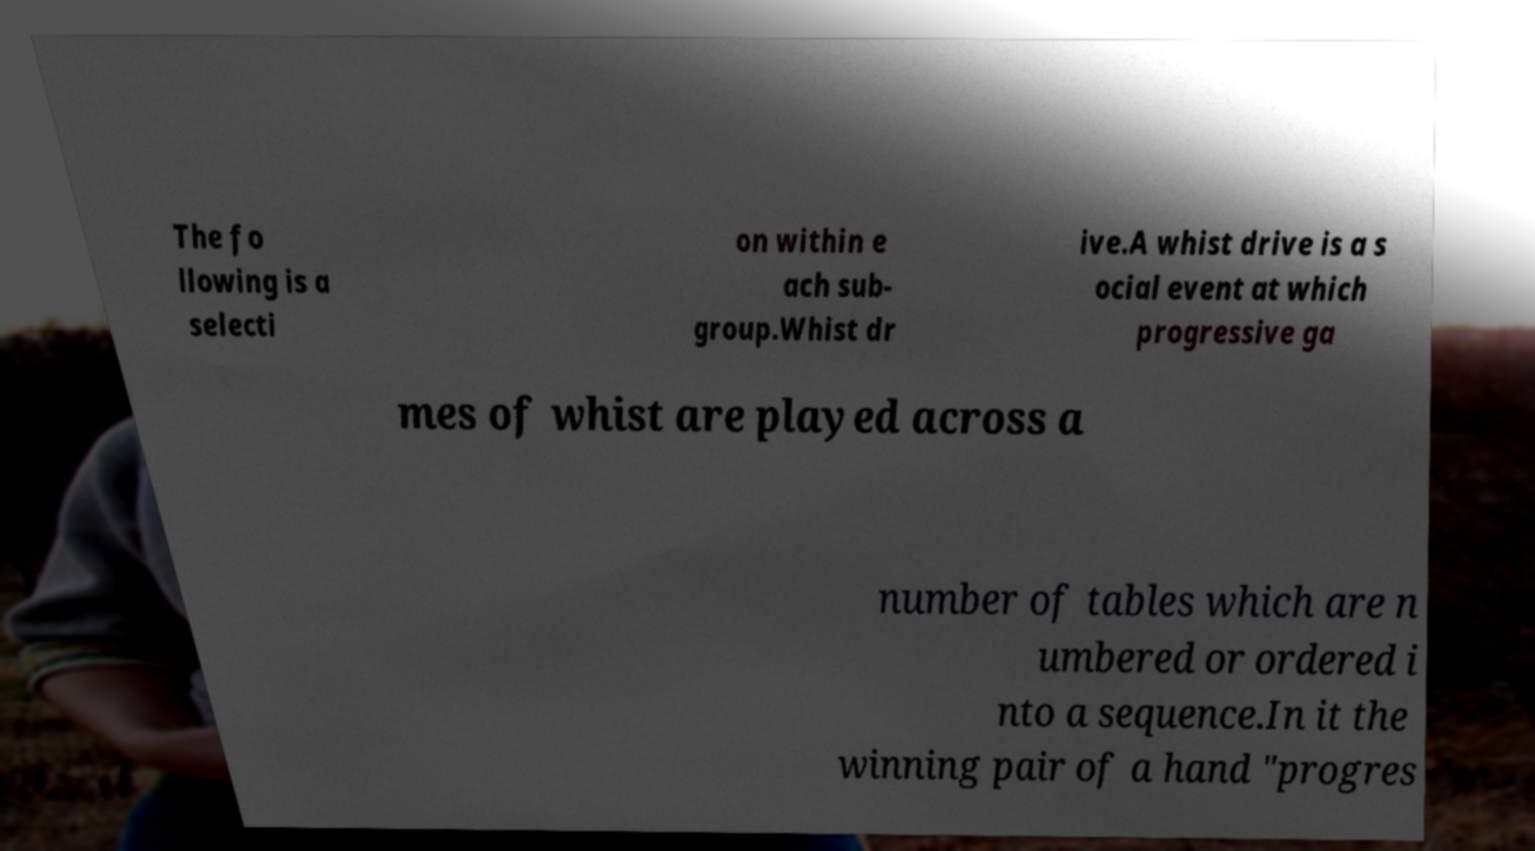Could you assist in decoding the text presented in this image and type it out clearly? The fo llowing is a selecti on within e ach sub- group.Whist dr ive.A whist drive is a s ocial event at which progressive ga mes of whist are played across a number of tables which are n umbered or ordered i nto a sequence.In it the winning pair of a hand "progres 